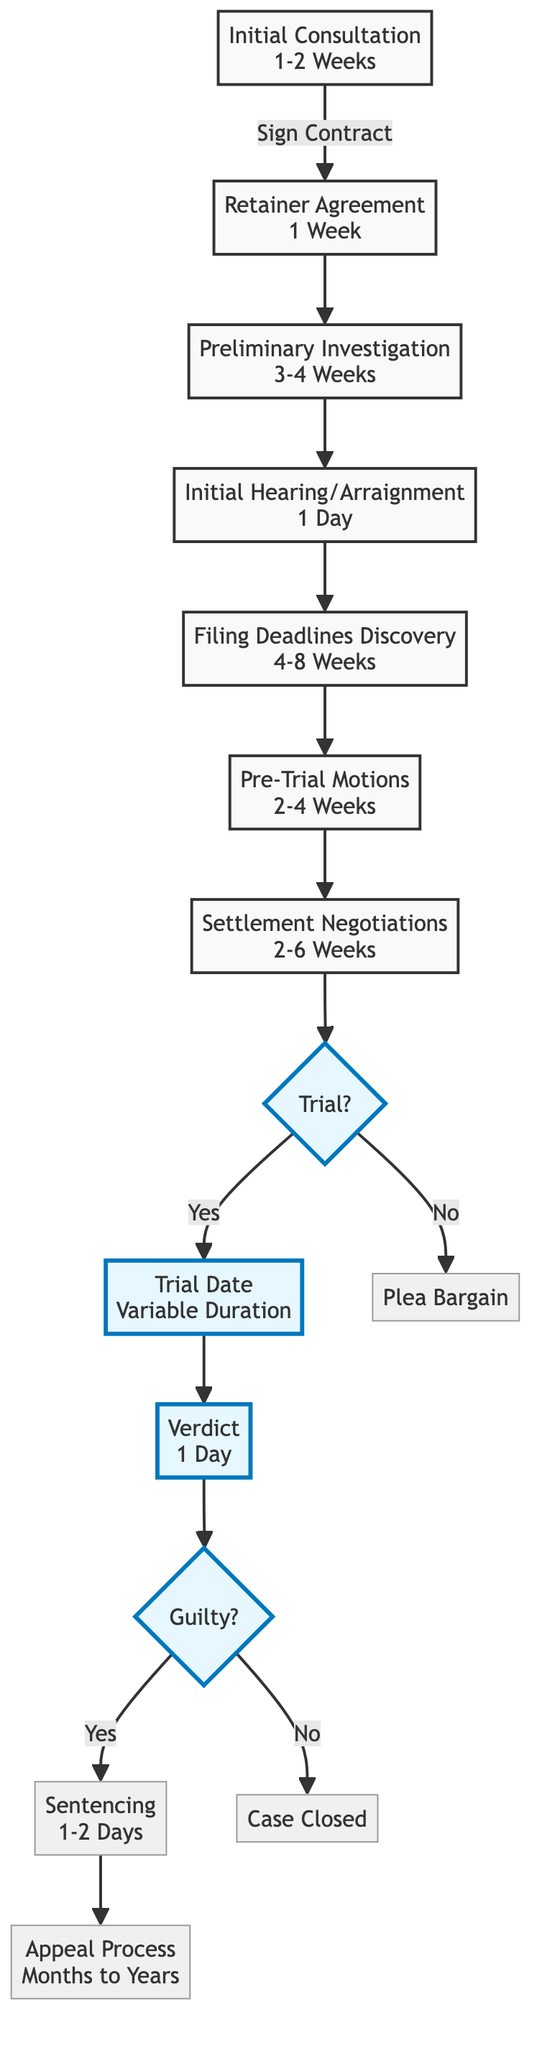What is the estimated duration of the Initial Hearing? The diagram specifies that the Initial Hearing or Arraignment stage has an estimated duration of 1 Day.
Answer: 1 Day What follows after the Preliminary Investigation? After the Preliminary Investigation stage, the flowchart shows that the next stage is the Initial Hearing/Arraignment.
Answer: Initial Hearing/Arraignment How many stages are related to trial outcomes? In the flowchart, there are three stages related to trial outcomes: Trial Date, Verdict, and Sentencing (if applicable).
Answer: Three What is the duration for Settlement Negotiations? According to the diagram, the Settlement Negotiations/Plea Bargaining stage has an estimated duration of 2-6 Weeks.
Answer: 2-6 Weeks What happens if the decision is Guilty at the Verdict stage? If the decision is Guilty at the Verdict stage, the next step according to the diagram is Sentencing.
Answer: Sentencing What is the relationship between Pre-Trial Motions and Settlement Negotiations? The diagram indicates that Pre-Trial Motions occur before Settlement Negotiations, establishing a sequence of events in the timeline.
Answer: Sequence How long can the Appeal Process take? The flowchart presents that the Appeal Process can take from Months to Years, specifying the duration.
Answer: Months to Years What determines if the trial proceeds from the Trial Decision stage? The flowchart illustrates that the decision to proceed to trial is determined by the question "Trial?" leading to the options Yes or No, depending on the case outcome.
Answer: Yes or No Which milestone comes directly before the filing deadlines? The milestone that comes directly before the Filing Deadlines (Discovery) is the Initial Hearing/Arraignment.
Answer: Initial Hearing/Arraignment 